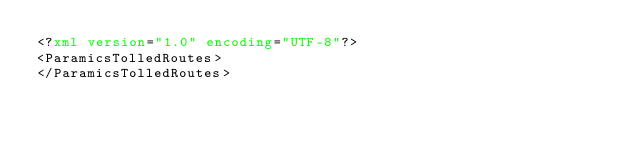<code> <loc_0><loc_0><loc_500><loc_500><_XML_><?xml version="1.0" encoding="UTF-8"?>
<ParamicsTolledRoutes>
</ParamicsTolledRoutes>
</code> 